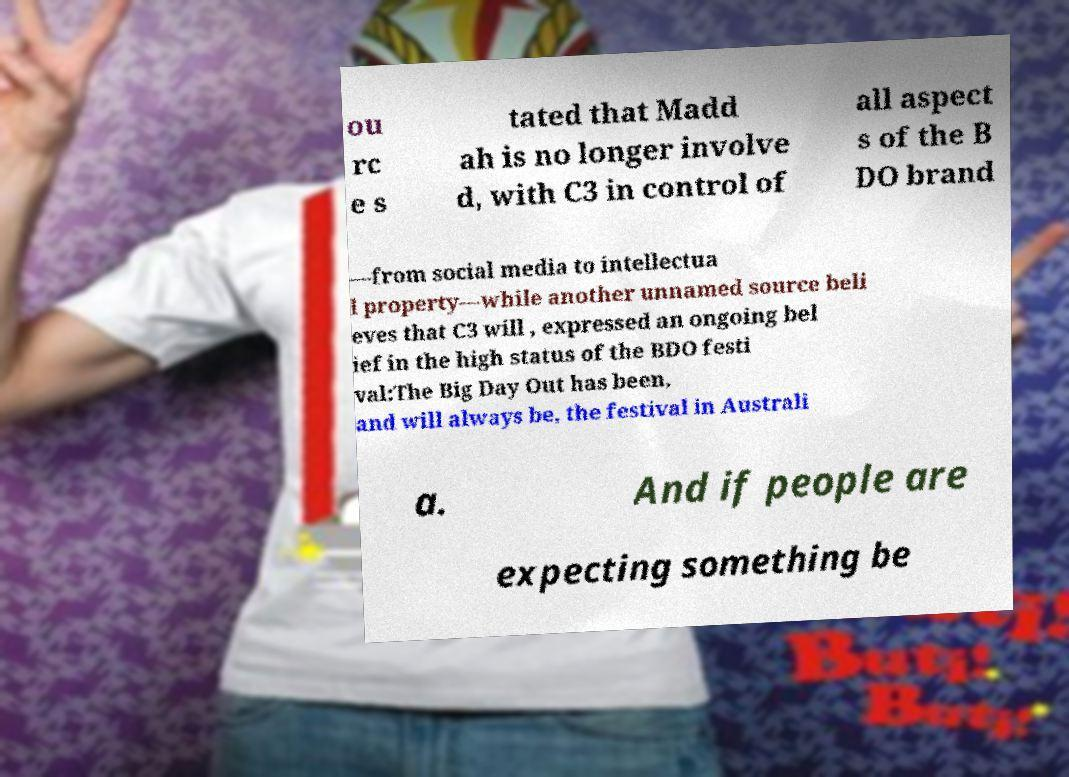What messages or text are displayed in this image? I need them in a readable, typed format. ou rc e s tated that Madd ah is no longer involve d, with C3 in control of all aspect s of the B DO brand —from social media to intellectua l property—while another unnamed source beli eves that C3 will , expressed an ongoing bel ief in the high status of the BDO festi val:The Big Day Out has been, and will always be, the festival in Australi a. And if people are expecting something be 